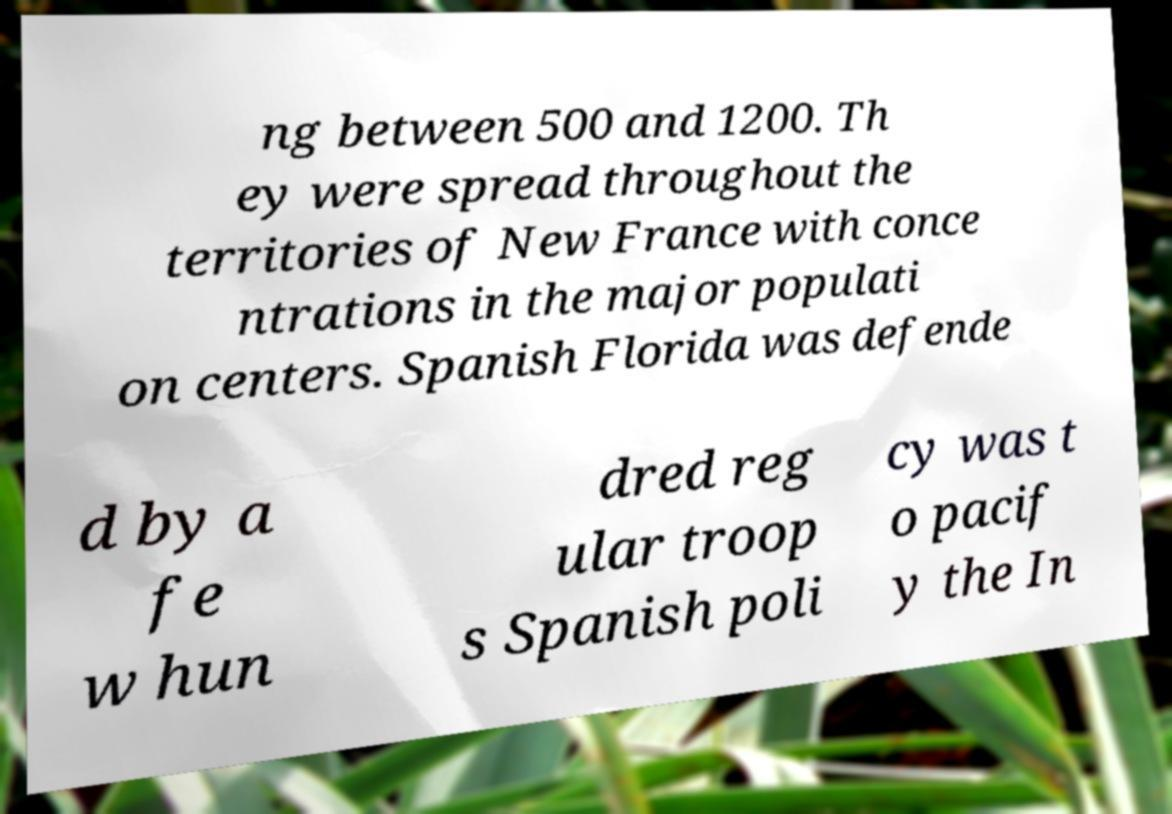Please read and relay the text visible in this image. What does it say? ng between 500 and 1200. Th ey were spread throughout the territories of New France with conce ntrations in the major populati on centers. Spanish Florida was defende d by a fe w hun dred reg ular troop s Spanish poli cy was t o pacif y the In 